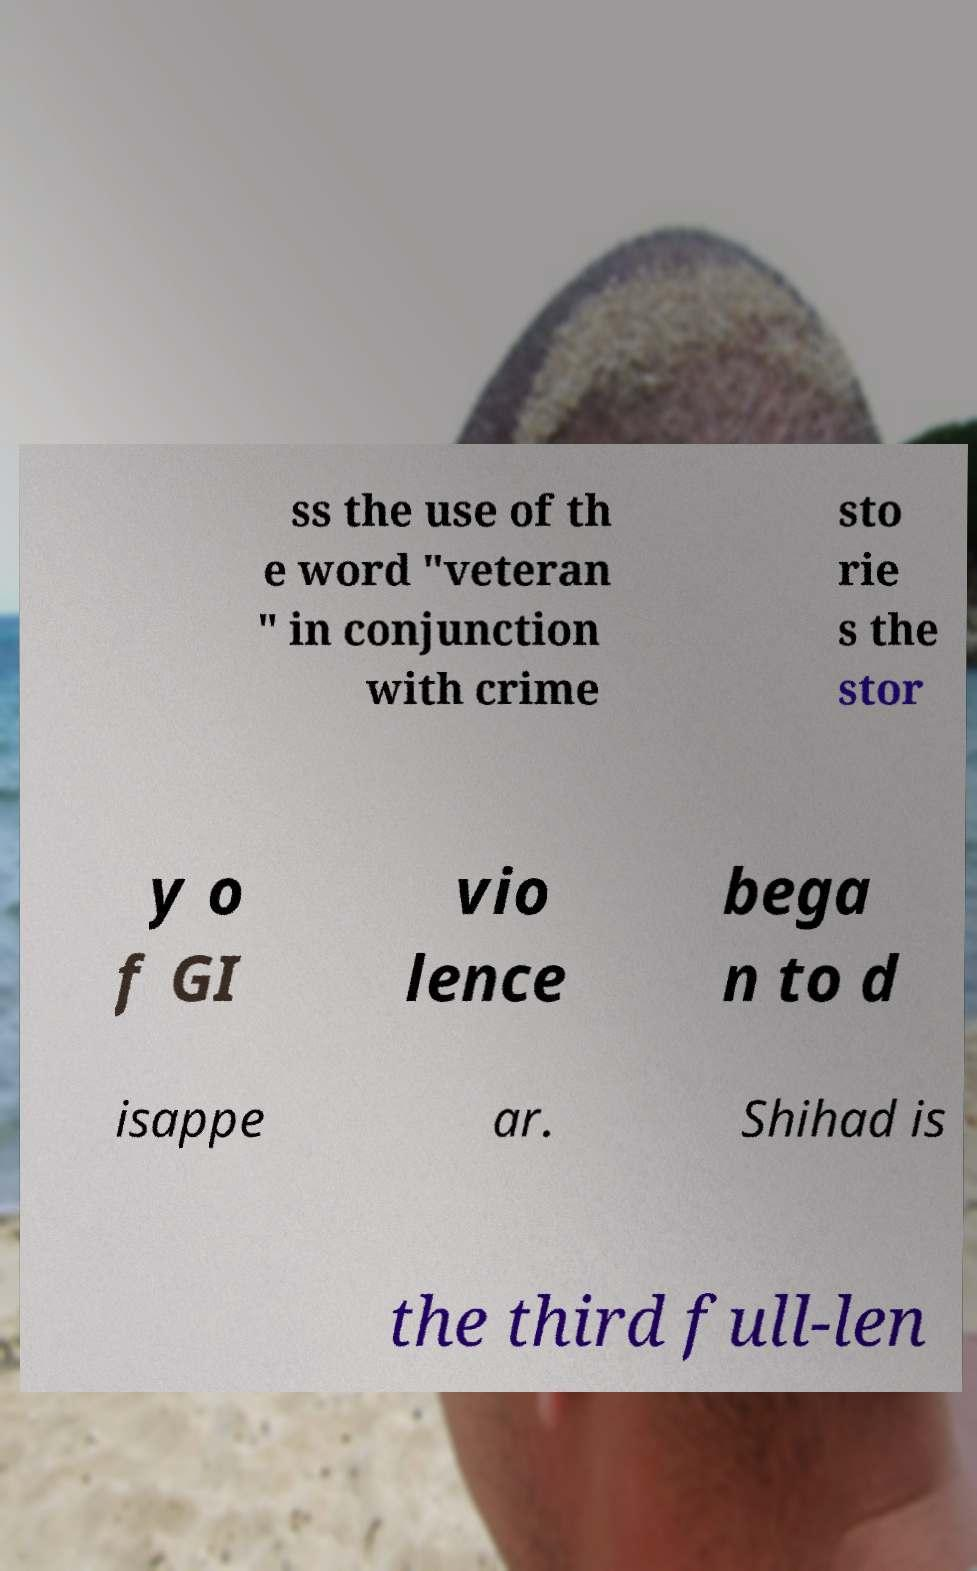There's text embedded in this image that I need extracted. Can you transcribe it verbatim? ss the use of th e word "veteran " in conjunction with crime sto rie s the stor y o f GI vio lence bega n to d isappe ar. Shihad is the third full-len 